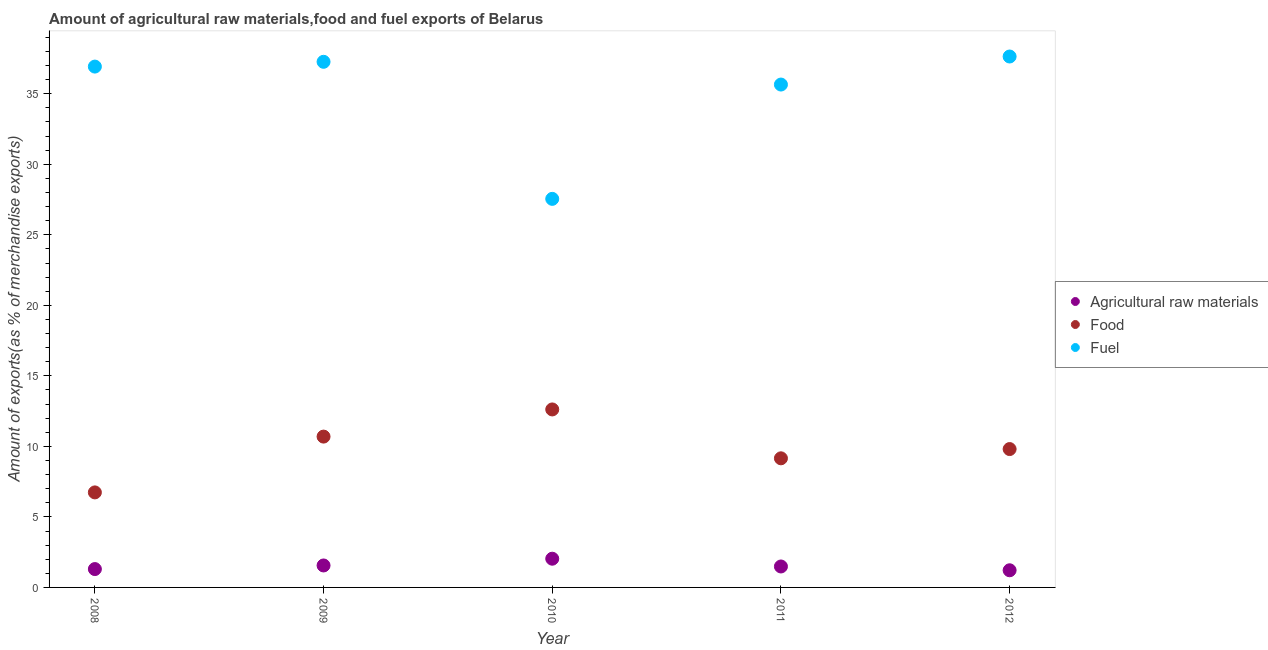What is the percentage of raw materials exports in 2008?
Make the answer very short. 1.3. Across all years, what is the maximum percentage of food exports?
Make the answer very short. 12.62. Across all years, what is the minimum percentage of fuel exports?
Your answer should be compact. 27.55. In which year was the percentage of raw materials exports minimum?
Your answer should be compact. 2012. What is the total percentage of food exports in the graph?
Ensure brevity in your answer.  49.01. What is the difference between the percentage of food exports in 2008 and that in 2010?
Your response must be concise. -5.88. What is the difference between the percentage of fuel exports in 2010 and the percentage of raw materials exports in 2008?
Provide a succinct answer. 26.25. What is the average percentage of food exports per year?
Offer a very short reply. 9.8. In the year 2012, what is the difference between the percentage of fuel exports and percentage of food exports?
Give a very brief answer. 27.83. In how many years, is the percentage of fuel exports greater than 24 %?
Ensure brevity in your answer.  5. What is the ratio of the percentage of food exports in 2011 to that in 2012?
Offer a very short reply. 0.93. What is the difference between the highest and the second highest percentage of fuel exports?
Keep it short and to the point. 0.38. What is the difference between the highest and the lowest percentage of food exports?
Offer a very short reply. 5.88. In how many years, is the percentage of fuel exports greater than the average percentage of fuel exports taken over all years?
Provide a succinct answer. 4. Is the sum of the percentage of fuel exports in 2011 and 2012 greater than the maximum percentage of raw materials exports across all years?
Provide a succinct answer. Yes. Does the percentage of food exports monotonically increase over the years?
Your answer should be compact. No. Is the percentage of fuel exports strictly greater than the percentage of food exports over the years?
Make the answer very short. Yes. Is the percentage of fuel exports strictly less than the percentage of raw materials exports over the years?
Provide a succinct answer. No. Are the values on the major ticks of Y-axis written in scientific E-notation?
Give a very brief answer. No. Does the graph contain any zero values?
Your response must be concise. No. Where does the legend appear in the graph?
Your answer should be very brief. Center right. How many legend labels are there?
Your answer should be very brief. 3. What is the title of the graph?
Your answer should be very brief. Amount of agricultural raw materials,food and fuel exports of Belarus. What is the label or title of the Y-axis?
Provide a short and direct response. Amount of exports(as % of merchandise exports). What is the Amount of exports(as % of merchandise exports) in Agricultural raw materials in 2008?
Keep it short and to the point. 1.3. What is the Amount of exports(as % of merchandise exports) in Food in 2008?
Ensure brevity in your answer.  6.74. What is the Amount of exports(as % of merchandise exports) in Fuel in 2008?
Give a very brief answer. 36.93. What is the Amount of exports(as % of merchandise exports) in Agricultural raw materials in 2009?
Provide a succinct answer. 1.56. What is the Amount of exports(as % of merchandise exports) in Food in 2009?
Your answer should be very brief. 10.69. What is the Amount of exports(as % of merchandise exports) of Fuel in 2009?
Your answer should be very brief. 37.27. What is the Amount of exports(as % of merchandise exports) in Agricultural raw materials in 2010?
Offer a very short reply. 2.04. What is the Amount of exports(as % of merchandise exports) in Food in 2010?
Your answer should be very brief. 12.62. What is the Amount of exports(as % of merchandise exports) of Fuel in 2010?
Give a very brief answer. 27.55. What is the Amount of exports(as % of merchandise exports) of Agricultural raw materials in 2011?
Keep it short and to the point. 1.48. What is the Amount of exports(as % of merchandise exports) in Food in 2011?
Keep it short and to the point. 9.15. What is the Amount of exports(as % of merchandise exports) of Fuel in 2011?
Provide a succinct answer. 35.65. What is the Amount of exports(as % of merchandise exports) of Agricultural raw materials in 2012?
Provide a short and direct response. 1.22. What is the Amount of exports(as % of merchandise exports) of Food in 2012?
Your answer should be compact. 9.81. What is the Amount of exports(as % of merchandise exports) in Fuel in 2012?
Provide a succinct answer. 37.64. Across all years, what is the maximum Amount of exports(as % of merchandise exports) in Agricultural raw materials?
Keep it short and to the point. 2.04. Across all years, what is the maximum Amount of exports(as % of merchandise exports) in Food?
Keep it short and to the point. 12.62. Across all years, what is the maximum Amount of exports(as % of merchandise exports) in Fuel?
Offer a terse response. 37.64. Across all years, what is the minimum Amount of exports(as % of merchandise exports) in Agricultural raw materials?
Make the answer very short. 1.22. Across all years, what is the minimum Amount of exports(as % of merchandise exports) in Food?
Your answer should be very brief. 6.74. Across all years, what is the minimum Amount of exports(as % of merchandise exports) of Fuel?
Make the answer very short. 27.55. What is the total Amount of exports(as % of merchandise exports) in Agricultural raw materials in the graph?
Your answer should be very brief. 7.6. What is the total Amount of exports(as % of merchandise exports) of Food in the graph?
Make the answer very short. 49.01. What is the total Amount of exports(as % of merchandise exports) of Fuel in the graph?
Your response must be concise. 175.04. What is the difference between the Amount of exports(as % of merchandise exports) of Agricultural raw materials in 2008 and that in 2009?
Provide a short and direct response. -0.26. What is the difference between the Amount of exports(as % of merchandise exports) of Food in 2008 and that in 2009?
Give a very brief answer. -3.96. What is the difference between the Amount of exports(as % of merchandise exports) of Fuel in 2008 and that in 2009?
Keep it short and to the point. -0.34. What is the difference between the Amount of exports(as % of merchandise exports) of Agricultural raw materials in 2008 and that in 2010?
Keep it short and to the point. -0.73. What is the difference between the Amount of exports(as % of merchandise exports) in Food in 2008 and that in 2010?
Provide a succinct answer. -5.88. What is the difference between the Amount of exports(as % of merchandise exports) of Fuel in 2008 and that in 2010?
Make the answer very short. 9.38. What is the difference between the Amount of exports(as % of merchandise exports) of Agricultural raw materials in 2008 and that in 2011?
Your response must be concise. -0.18. What is the difference between the Amount of exports(as % of merchandise exports) in Food in 2008 and that in 2011?
Your answer should be very brief. -2.42. What is the difference between the Amount of exports(as % of merchandise exports) of Fuel in 2008 and that in 2011?
Offer a very short reply. 1.27. What is the difference between the Amount of exports(as % of merchandise exports) of Agricultural raw materials in 2008 and that in 2012?
Provide a succinct answer. 0.09. What is the difference between the Amount of exports(as % of merchandise exports) in Food in 2008 and that in 2012?
Your answer should be compact. -3.07. What is the difference between the Amount of exports(as % of merchandise exports) of Fuel in 2008 and that in 2012?
Your answer should be compact. -0.71. What is the difference between the Amount of exports(as % of merchandise exports) in Agricultural raw materials in 2009 and that in 2010?
Make the answer very short. -0.48. What is the difference between the Amount of exports(as % of merchandise exports) in Food in 2009 and that in 2010?
Offer a very short reply. -1.93. What is the difference between the Amount of exports(as % of merchandise exports) in Fuel in 2009 and that in 2010?
Offer a terse response. 9.72. What is the difference between the Amount of exports(as % of merchandise exports) of Agricultural raw materials in 2009 and that in 2011?
Provide a short and direct response. 0.07. What is the difference between the Amount of exports(as % of merchandise exports) in Food in 2009 and that in 2011?
Your answer should be very brief. 1.54. What is the difference between the Amount of exports(as % of merchandise exports) of Fuel in 2009 and that in 2011?
Offer a very short reply. 1.61. What is the difference between the Amount of exports(as % of merchandise exports) of Agricultural raw materials in 2009 and that in 2012?
Offer a very short reply. 0.34. What is the difference between the Amount of exports(as % of merchandise exports) of Food in 2009 and that in 2012?
Your answer should be compact. 0.88. What is the difference between the Amount of exports(as % of merchandise exports) of Fuel in 2009 and that in 2012?
Ensure brevity in your answer.  -0.38. What is the difference between the Amount of exports(as % of merchandise exports) in Agricultural raw materials in 2010 and that in 2011?
Your answer should be very brief. 0.55. What is the difference between the Amount of exports(as % of merchandise exports) in Food in 2010 and that in 2011?
Offer a terse response. 3.47. What is the difference between the Amount of exports(as % of merchandise exports) in Fuel in 2010 and that in 2011?
Your answer should be very brief. -8.1. What is the difference between the Amount of exports(as % of merchandise exports) in Agricultural raw materials in 2010 and that in 2012?
Give a very brief answer. 0.82. What is the difference between the Amount of exports(as % of merchandise exports) of Food in 2010 and that in 2012?
Offer a terse response. 2.81. What is the difference between the Amount of exports(as % of merchandise exports) in Fuel in 2010 and that in 2012?
Ensure brevity in your answer.  -10.09. What is the difference between the Amount of exports(as % of merchandise exports) in Agricultural raw materials in 2011 and that in 2012?
Provide a short and direct response. 0.27. What is the difference between the Amount of exports(as % of merchandise exports) in Food in 2011 and that in 2012?
Give a very brief answer. -0.66. What is the difference between the Amount of exports(as % of merchandise exports) of Fuel in 2011 and that in 2012?
Keep it short and to the point. -1.99. What is the difference between the Amount of exports(as % of merchandise exports) of Agricultural raw materials in 2008 and the Amount of exports(as % of merchandise exports) of Food in 2009?
Give a very brief answer. -9.39. What is the difference between the Amount of exports(as % of merchandise exports) of Agricultural raw materials in 2008 and the Amount of exports(as % of merchandise exports) of Fuel in 2009?
Ensure brevity in your answer.  -35.96. What is the difference between the Amount of exports(as % of merchandise exports) of Food in 2008 and the Amount of exports(as % of merchandise exports) of Fuel in 2009?
Provide a short and direct response. -30.53. What is the difference between the Amount of exports(as % of merchandise exports) in Agricultural raw materials in 2008 and the Amount of exports(as % of merchandise exports) in Food in 2010?
Give a very brief answer. -11.32. What is the difference between the Amount of exports(as % of merchandise exports) in Agricultural raw materials in 2008 and the Amount of exports(as % of merchandise exports) in Fuel in 2010?
Provide a short and direct response. -26.25. What is the difference between the Amount of exports(as % of merchandise exports) of Food in 2008 and the Amount of exports(as % of merchandise exports) of Fuel in 2010?
Your response must be concise. -20.81. What is the difference between the Amount of exports(as % of merchandise exports) in Agricultural raw materials in 2008 and the Amount of exports(as % of merchandise exports) in Food in 2011?
Provide a succinct answer. -7.85. What is the difference between the Amount of exports(as % of merchandise exports) of Agricultural raw materials in 2008 and the Amount of exports(as % of merchandise exports) of Fuel in 2011?
Ensure brevity in your answer.  -34.35. What is the difference between the Amount of exports(as % of merchandise exports) of Food in 2008 and the Amount of exports(as % of merchandise exports) of Fuel in 2011?
Provide a succinct answer. -28.92. What is the difference between the Amount of exports(as % of merchandise exports) in Agricultural raw materials in 2008 and the Amount of exports(as % of merchandise exports) in Food in 2012?
Give a very brief answer. -8.51. What is the difference between the Amount of exports(as % of merchandise exports) in Agricultural raw materials in 2008 and the Amount of exports(as % of merchandise exports) in Fuel in 2012?
Make the answer very short. -36.34. What is the difference between the Amount of exports(as % of merchandise exports) of Food in 2008 and the Amount of exports(as % of merchandise exports) of Fuel in 2012?
Make the answer very short. -30.9. What is the difference between the Amount of exports(as % of merchandise exports) in Agricultural raw materials in 2009 and the Amount of exports(as % of merchandise exports) in Food in 2010?
Make the answer very short. -11.06. What is the difference between the Amount of exports(as % of merchandise exports) of Agricultural raw materials in 2009 and the Amount of exports(as % of merchandise exports) of Fuel in 2010?
Your response must be concise. -25.99. What is the difference between the Amount of exports(as % of merchandise exports) of Food in 2009 and the Amount of exports(as % of merchandise exports) of Fuel in 2010?
Make the answer very short. -16.86. What is the difference between the Amount of exports(as % of merchandise exports) of Agricultural raw materials in 2009 and the Amount of exports(as % of merchandise exports) of Food in 2011?
Your response must be concise. -7.6. What is the difference between the Amount of exports(as % of merchandise exports) of Agricultural raw materials in 2009 and the Amount of exports(as % of merchandise exports) of Fuel in 2011?
Your answer should be compact. -34.1. What is the difference between the Amount of exports(as % of merchandise exports) in Food in 2009 and the Amount of exports(as % of merchandise exports) in Fuel in 2011?
Make the answer very short. -24.96. What is the difference between the Amount of exports(as % of merchandise exports) of Agricultural raw materials in 2009 and the Amount of exports(as % of merchandise exports) of Food in 2012?
Provide a succinct answer. -8.25. What is the difference between the Amount of exports(as % of merchandise exports) in Agricultural raw materials in 2009 and the Amount of exports(as % of merchandise exports) in Fuel in 2012?
Offer a terse response. -36.08. What is the difference between the Amount of exports(as % of merchandise exports) in Food in 2009 and the Amount of exports(as % of merchandise exports) in Fuel in 2012?
Your response must be concise. -26.95. What is the difference between the Amount of exports(as % of merchandise exports) in Agricultural raw materials in 2010 and the Amount of exports(as % of merchandise exports) in Food in 2011?
Offer a terse response. -7.12. What is the difference between the Amount of exports(as % of merchandise exports) of Agricultural raw materials in 2010 and the Amount of exports(as % of merchandise exports) of Fuel in 2011?
Provide a short and direct response. -33.62. What is the difference between the Amount of exports(as % of merchandise exports) of Food in 2010 and the Amount of exports(as % of merchandise exports) of Fuel in 2011?
Keep it short and to the point. -23.03. What is the difference between the Amount of exports(as % of merchandise exports) of Agricultural raw materials in 2010 and the Amount of exports(as % of merchandise exports) of Food in 2012?
Make the answer very short. -7.77. What is the difference between the Amount of exports(as % of merchandise exports) in Agricultural raw materials in 2010 and the Amount of exports(as % of merchandise exports) in Fuel in 2012?
Your answer should be very brief. -35.61. What is the difference between the Amount of exports(as % of merchandise exports) in Food in 2010 and the Amount of exports(as % of merchandise exports) in Fuel in 2012?
Your answer should be very brief. -25.02. What is the difference between the Amount of exports(as % of merchandise exports) in Agricultural raw materials in 2011 and the Amount of exports(as % of merchandise exports) in Food in 2012?
Your response must be concise. -8.33. What is the difference between the Amount of exports(as % of merchandise exports) in Agricultural raw materials in 2011 and the Amount of exports(as % of merchandise exports) in Fuel in 2012?
Keep it short and to the point. -36.16. What is the difference between the Amount of exports(as % of merchandise exports) of Food in 2011 and the Amount of exports(as % of merchandise exports) of Fuel in 2012?
Offer a terse response. -28.49. What is the average Amount of exports(as % of merchandise exports) of Agricultural raw materials per year?
Keep it short and to the point. 1.52. What is the average Amount of exports(as % of merchandise exports) of Food per year?
Keep it short and to the point. 9.8. What is the average Amount of exports(as % of merchandise exports) of Fuel per year?
Offer a very short reply. 35.01. In the year 2008, what is the difference between the Amount of exports(as % of merchandise exports) in Agricultural raw materials and Amount of exports(as % of merchandise exports) in Food?
Your answer should be compact. -5.44. In the year 2008, what is the difference between the Amount of exports(as % of merchandise exports) of Agricultural raw materials and Amount of exports(as % of merchandise exports) of Fuel?
Provide a succinct answer. -35.63. In the year 2008, what is the difference between the Amount of exports(as % of merchandise exports) in Food and Amount of exports(as % of merchandise exports) in Fuel?
Your answer should be very brief. -30.19. In the year 2009, what is the difference between the Amount of exports(as % of merchandise exports) of Agricultural raw materials and Amount of exports(as % of merchandise exports) of Food?
Your answer should be compact. -9.14. In the year 2009, what is the difference between the Amount of exports(as % of merchandise exports) in Agricultural raw materials and Amount of exports(as % of merchandise exports) in Fuel?
Offer a very short reply. -35.71. In the year 2009, what is the difference between the Amount of exports(as % of merchandise exports) in Food and Amount of exports(as % of merchandise exports) in Fuel?
Give a very brief answer. -26.57. In the year 2010, what is the difference between the Amount of exports(as % of merchandise exports) in Agricultural raw materials and Amount of exports(as % of merchandise exports) in Food?
Offer a very short reply. -10.58. In the year 2010, what is the difference between the Amount of exports(as % of merchandise exports) of Agricultural raw materials and Amount of exports(as % of merchandise exports) of Fuel?
Ensure brevity in your answer.  -25.51. In the year 2010, what is the difference between the Amount of exports(as % of merchandise exports) of Food and Amount of exports(as % of merchandise exports) of Fuel?
Keep it short and to the point. -14.93. In the year 2011, what is the difference between the Amount of exports(as % of merchandise exports) in Agricultural raw materials and Amount of exports(as % of merchandise exports) in Food?
Provide a succinct answer. -7.67. In the year 2011, what is the difference between the Amount of exports(as % of merchandise exports) of Agricultural raw materials and Amount of exports(as % of merchandise exports) of Fuel?
Provide a short and direct response. -34.17. In the year 2011, what is the difference between the Amount of exports(as % of merchandise exports) in Food and Amount of exports(as % of merchandise exports) in Fuel?
Provide a succinct answer. -26.5. In the year 2012, what is the difference between the Amount of exports(as % of merchandise exports) in Agricultural raw materials and Amount of exports(as % of merchandise exports) in Food?
Provide a succinct answer. -8.59. In the year 2012, what is the difference between the Amount of exports(as % of merchandise exports) of Agricultural raw materials and Amount of exports(as % of merchandise exports) of Fuel?
Provide a short and direct response. -36.43. In the year 2012, what is the difference between the Amount of exports(as % of merchandise exports) of Food and Amount of exports(as % of merchandise exports) of Fuel?
Your answer should be compact. -27.83. What is the ratio of the Amount of exports(as % of merchandise exports) in Agricultural raw materials in 2008 to that in 2009?
Your answer should be compact. 0.84. What is the ratio of the Amount of exports(as % of merchandise exports) in Food in 2008 to that in 2009?
Your answer should be very brief. 0.63. What is the ratio of the Amount of exports(as % of merchandise exports) of Fuel in 2008 to that in 2009?
Your answer should be very brief. 0.99. What is the ratio of the Amount of exports(as % of merchandise exports) of Agricultural raw materials in 2008 to that in 2010?
Your answer should be very brief. 0.64. What is the ratio of the Amount of exports(as % of merchandise exports) in Food in 2008 to that in 2010?
Ensure brevity in your answer.  0.53. What is the ratio of the Amount of exports(as % of merchandise exports) of Fuel in 2008 to that in 2010?
Your answer should be compact. 1.34. What is the ratio of the Amount of exports(as % of merchandise exports) of Agricultural raw materials in 2008 to that in 2011?
Ensure brevity in your answer.  0.88. What is the ratio of the Amount of exports(as % of merchandise exports) of Food in 2008 to that in 2011?
Offer a very short reply. 0.74. What is the ratio of the Amount of exports(as % of merchandise exports) of Fuel in 2008 to that in 2011?
Provide a short and direct response. 1.04. What is the ratio of the Amount of exports(as % of merchandise exports) of Agricultural raw materials in 2008 to that in 2012?
Give a very brief answer. 1.07. What is the ratio of the Amount of exports(as % of merchandise exports) of Food in 2008 to that in 2012?
Your response must be concise. 0.69. What is the ratio of the Amount of exports(as % of merchandise exports) of Agricultural raw materials in 2009 to that in 2010?
Offer a very short reply. 0.76. What is the ratio of the Amount of exports(as % of merchandise exports) in Food in 2009 to that in 2010?
Make the answer very short. 0.85. What is the ratio of the Amount of exports(as % of merchandise exports) in Fuel in 2009 to that in 2010?
Provide a succinct answer. 1.35. What is the ratio of the Amount of exports(as % of merchandise exports) of Agricultural raw materials in 2009 to that in 2011?
Make the answer very short. 1.05. What is the ratio of the Amount of exports(as % of merchandise exports) of Food in 2009 to that in 2011?
Give a very brief answer. 1.17. What is the ratio of the Amount of exports(as % of merchandise exports) of Fuel in 2009 to that in 2011?
Provide a short and direct response. 1.05. What is the ratio of the Amount of exports(as % of merchandise exports) of Agricultural raw materials in 2009 to that in 2012?
Offer a very short reply. 1.28. What is the ratio of the Amount of exports(as % of merchandise exports) of Food in 2009 to that in 2012?
Your response must be concise. 1.09. What is the ratio of the Amount of exports(as % of merchandise exports) of Agricultural raw materials in 2010 to that in 2011?
Ensure brevity in your answer.  1.37. What is the ratio of the Amount of exports(as % of merchandise exports) of Food in 2010 to that in 2011?
Give a very brief answer. 1.38. What is the ratio of the Amount of exports(as % of merchandise exports) of Fuel in 2010 to that in 2011?
Keep it short and to the point. 0.77. What is the ratio of the Amount of exports(as % of merchandise exports) of Agricultural raw materials in 2010 to that in 2012?
Give a very brief answer. 1.67. What is the ratio of the Amount of exports(as % of merchandise exports) of Food in 2010 to that in 2012?
Keep it short and to the point. 1.29. What is the ratio of the Amount of exports(as % of merchandise exports) in Fuel in 2010 to that in 2012?
Ensure brevity in your answer.  0.73. What is the ratio of the Amount of exports(as % of merchandise exports) of Agricultural raw materials in 2011 to that in 2012?
Offer a terse response. 1.22. What is the ratio of the Amount of exports(as % of merchandise exports) in Food in 2011 to that in 2012?
Ensure brevity in your answer.  0.93. What is the ratio of the Amount of exports(as % of merchandise exports) of Fuel in 2011 to that in 2012?
Your answer should be compact. 0.95. What is the difference between the highest and the second highest Amount of exports(as % of merchandise exports) in Agricultural raw materials?
Make the answer very short. 0.48. What is the difference between the highest and the second highest Amount of exports(as % of merchandise exports) of Food?
Offer a terse response. 1.93. What is the difference between the highest and the second highest Amount of exports(as % of merchandise exports) of Fuel?
Offer a very short reply. 0.38. What is the difference between the highest and the lowest Amount of exports(as % of merchandise exports) of Agricultural raw materials?
Offer a terse response. 0.82. What is the difference between the highest and the lowest Amount of exports(as % of merchandise exports) of Food?
Your response must be concise. 5.88. What is the difference between the highest and the lowest Amount of exports(as % of merchandise exports) in Fuel?
Offer a very short reply. 10.09. 